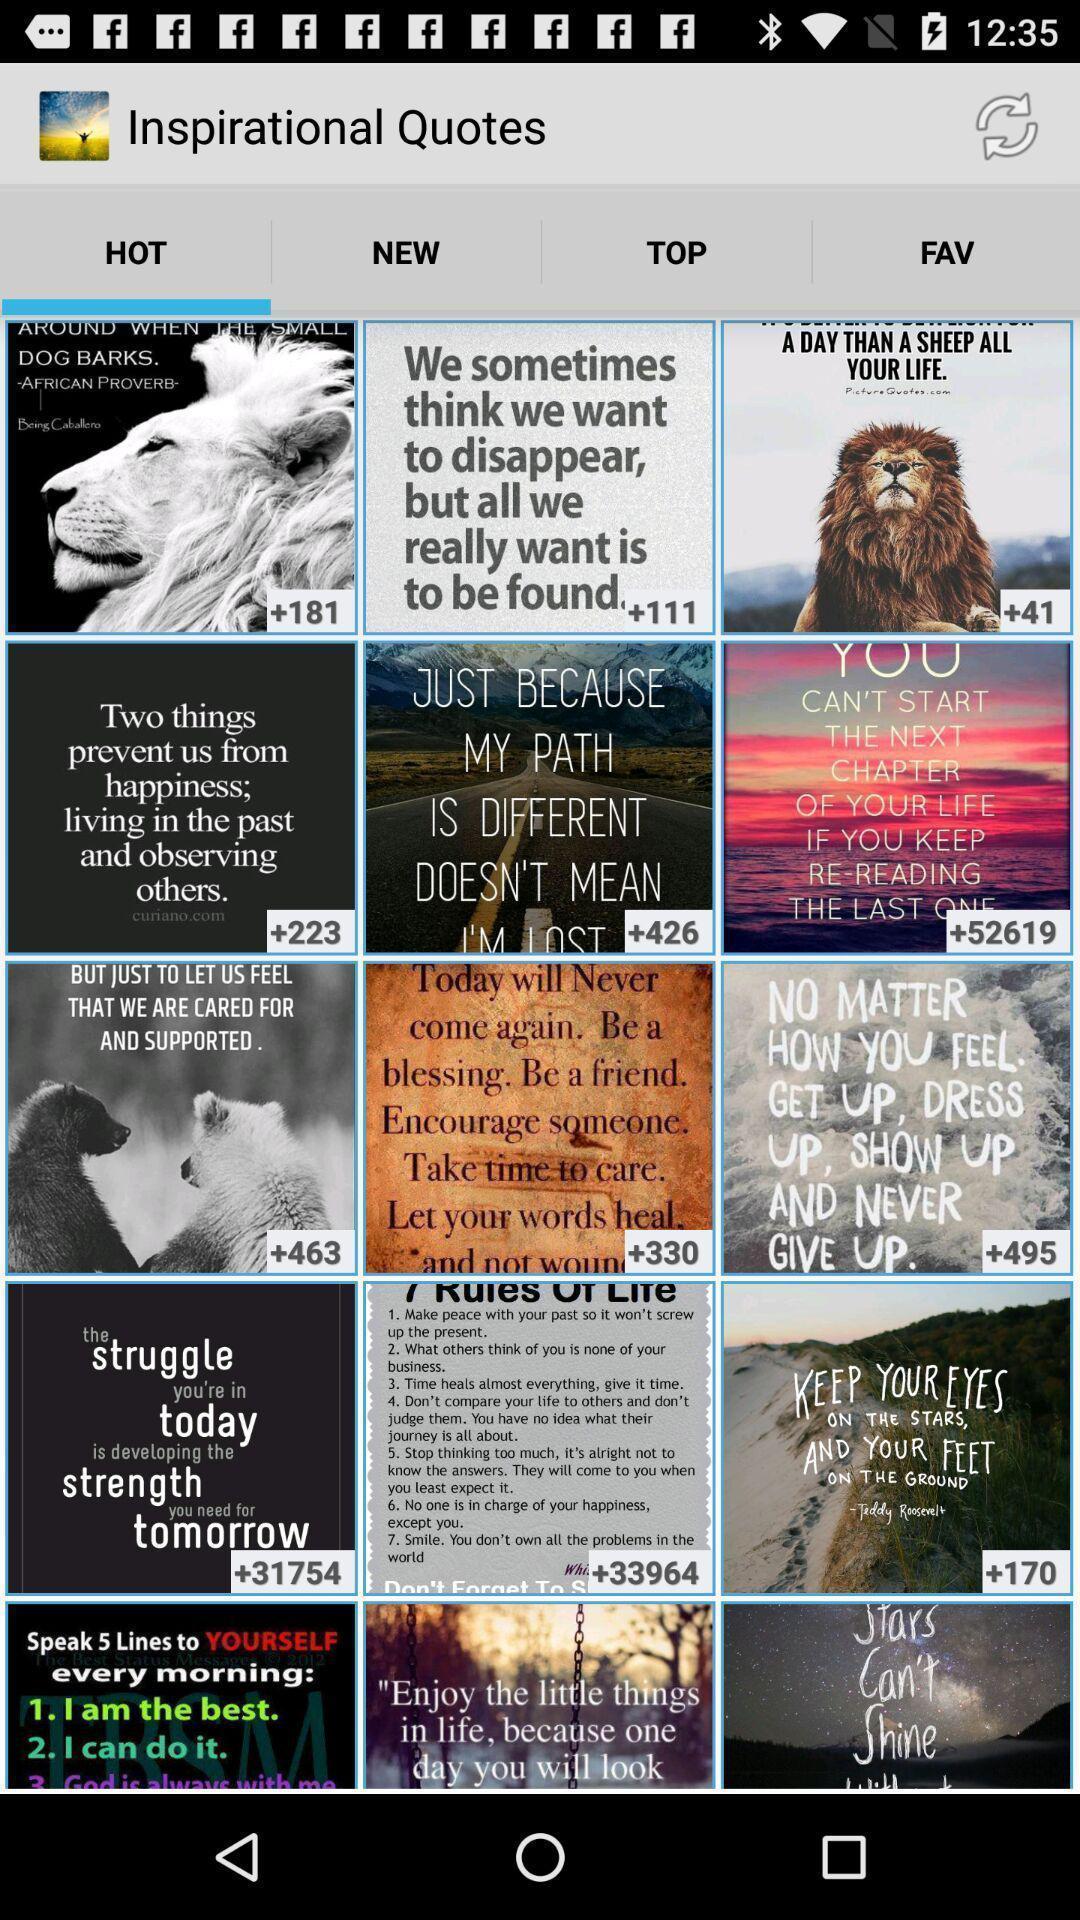What details can you identify in this image? Screen presenting lot of quotes. 